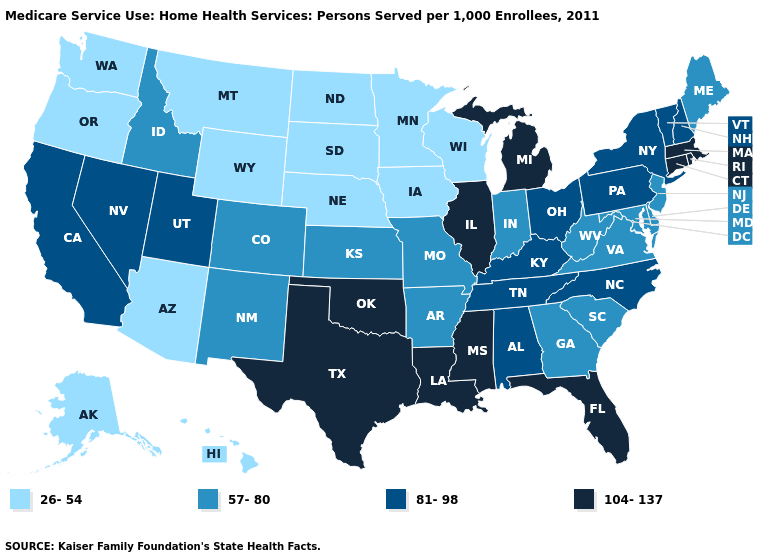Name the states that have a value in the range 26-54?
Concise answer only. Alaska, Arizona, Hawaii, Iowa, Minnesota, Montana, Nebraska, North Dakota, Oregon, South Dakota, Washington, Wisconsin, Wyoming. What is the value of Idaho?
Write a very short answer. 57-80. Name the states that have a value in the range 57-80?
Quick response, please. Arkansas, Colorado, Delaware, Georgia, Idaho, Indiana, Kansas, Maine, Maryland, Missouri, New Jersey, New Mexico, South Carolina, Virginia, West Virginia. What is the lowest value in states that border Colorado?
Be succinct. 26-54. What is the highest value in the Northeast ?
Concise answer only. 104-137. Name the states that have a value in the range 104-137?
Quick response, please. Connecticut, Florida, Illinois, Louisiana, Massachusetts, Michigan, Mississippi, Oklahoma, Rhode Island, Texas. Does Hawaii have the highest value in the USA?
Answer briefly. No. Name the states that have a value in the range 81-98?
Short answer required. Alabama, California, Kentucky, Nevada, New Hampshire, New York, North Carolina, Ohio, Pennsylvania, Tennessee, Utah, Vermont. What is the lowest value in states that border Oregon?
Answer briefly. 26-54. Which states hav the highest value in the West?
Give a very brief answer. California, Nevada, Utah. Name the states that have a value in the range 81-98?
Concise answer only. Alabama, California, Kentucky, Nevada, New Hampshire, New York, North Carolina, Ohio, Pennsylvania, Tennessee, Utah, Vermont. Name the states that have a value in the range 57-80?
Answer briefly. Arkansas, Colorado, Delaware, Georgia, Idaho, Indiana, Kansas, Maine, Maryland, Missouri, New Jersey, New Mexico, South Carolina, Virginia, West Virginia. Name the states that have a value in the range 81-98?
Answer briefly. Alabama, California, Kentucky, Nevada, New Hampshire, New York, North Carolina, Ohio, Pennsylvania, Tennessee, Utah, Vermont. Which states have the lowest value in the USA?
Quick response, please. Alaska, Arizona, Hawaii, Iowa, Minnesota, Montana, Nebraska, North Dakota, Oregon, South Dakota, Washington, Wisconsin, Wyoming. Does Michigan have the highest value in the USA?
Be succinct. Yes. 